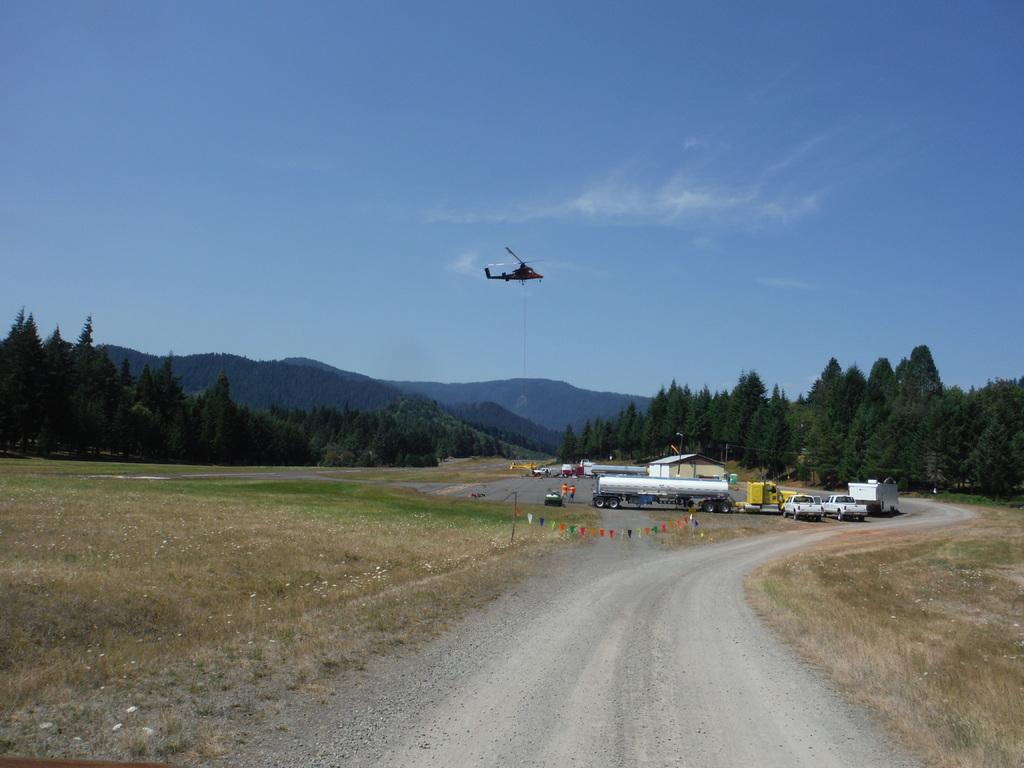Describe this image in one or two sentences. In the image there is a road and on the either side of the road there is a grass surface, in the distance there are few vehicles and around the vehicles there are many trees and there is a helicopter flying in the air, in the background there are mountains. 